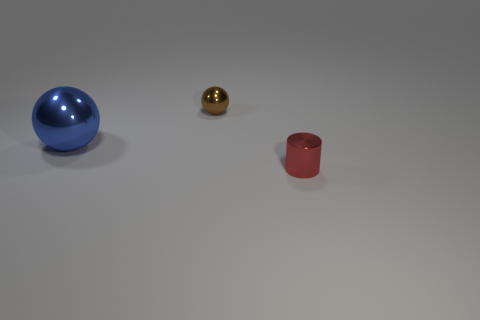How many other objects are there of the same size as the cylinder?
Offer a terse response. 1. What size is the metal object that is both in front of the tiny brown shiny thing and to the left of the red thing?
Provide a succinct answer. Large. Is there a blue metal thing that has the same shape as the small brown thing?
Your response must be concise. Yes. What number of things are tiny matte cubes or metallic spheres that are on the right side of the large blue metal object?
Offer a terse response. 1. What number of other things are made of the same material as the red cylinder?
Give a very brief answer. 2. What number of things are either small things or metal things?
Your response must be concise. 3. Is the number of metallic objects to the left of the small brown object greater than the number of red metal objects to the right of the red thing?
Ensure brevity in your answer.  Yes. There is a tiny shiny object that is in front of the big blue metallic ball; is it the same color as the small shiny object that is behind the large blue shiny object?
Provide a succinct answer. No. There is a sphere on the right side of the shiny sphere that is on the left side of the tiny shiny object that is left of the tiny red metallic object; what is its size?
Provide a short and direct response. Small. The other object that is the same shape as the big thing is what color?
Give a very brief answer. Brown. 